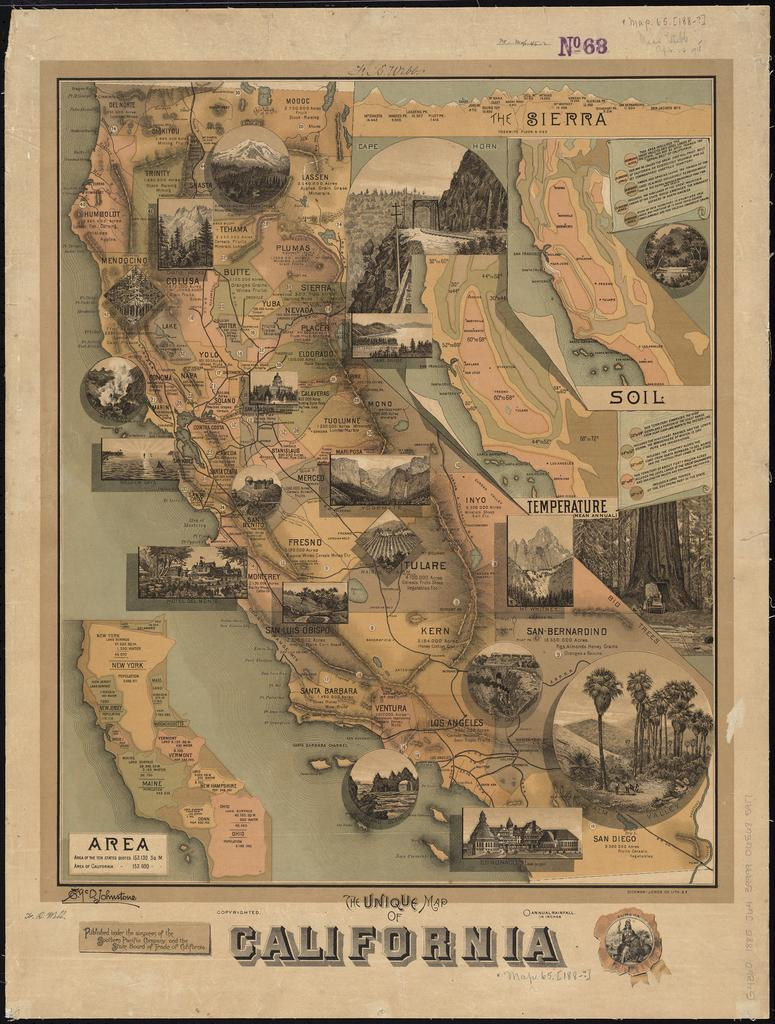<image>
Give a short and clear explanation of the subsequent image. California featured on a diagram, the number of the image is 68. 